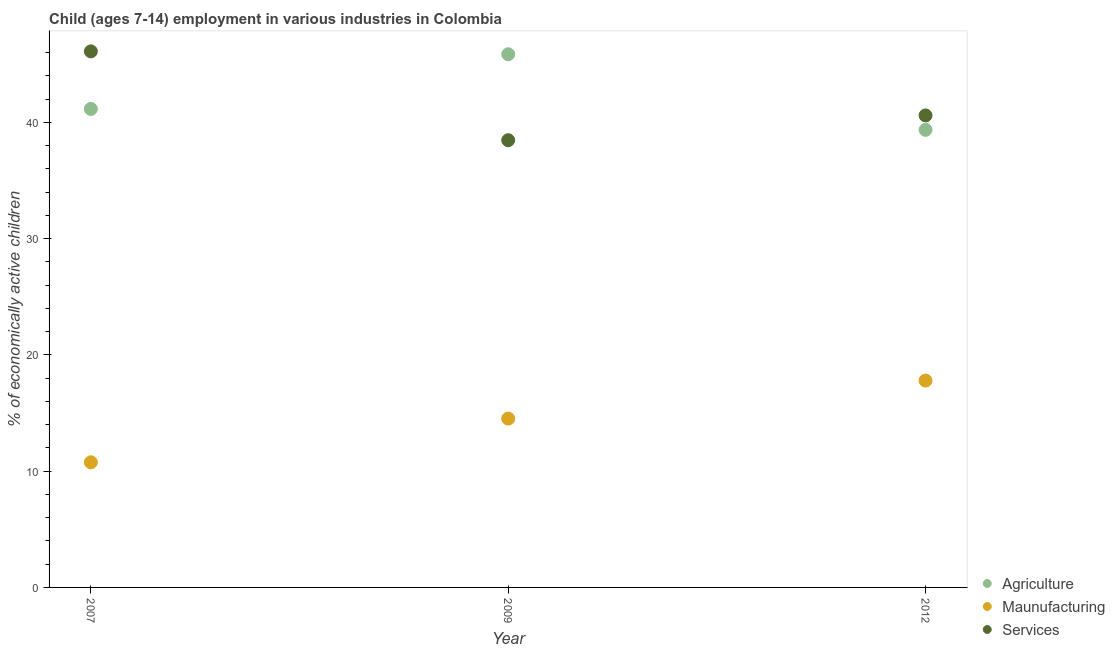What is the percentage of economically active children in manufacturing in 2012?
Offer a terse response. 17.79. Across all years, what is the maximum percentage of economically active children in agriculture?
Your answer should be very brief. 45.85. Across all years, what is the minimum percentage of economically active children in services?
Ensure brevity in your answer.  38.46. In which year was the percentage of economically active children in services minimum?
Ensure brevity in your answer.  2009. What is the total percentage of economically active children in manufacturing in the graph?
Ensure brevity in your answer.  43.07. What is the difference between the percentage of economically active children in services in 2007 and the percentage of economically active children in agriculture in 2012?
Your answer should be compact. 6.75. What is the average percentage of economically active children in services per year?
Provide a succinct answer. 41.72. In the year 2007, what is the difference between the percentage of economically active children in services and percentage of economically active children in manufacturing?
Give a very brief answer. 35.34. What is the ratio of the percentage of economically active children in manufacturing in 2007 to that in 2009?
Keep it short and to the point. 0.74. Is the percentage of economically active children in manufacturing in 2007 less than that in 2009?
Give a very brief answer. Yes. Is the difference between the percentage of economically active children in agriculture in 2007 and 2012 greater than the difference between the percentage of economically active children in manufacturing in 2007 and 2012?
Ensure brevity in your answer.  Yes. What is the difference between the highest and the second highest percentage of economically active children in agriculture?
Keep it short and to the point. 4.7. What is the difference between the highest and the lowest percentage of economically active children in services?
Your answer should be compact. 7.64. In how many years, is the percentage of economically active children in services greater than the average percentage of economically active children in services taken over all years?
Provide a short and direct response. 1. Is the sum of the percentage of economically active children in services in 2007 and 2009 greater than the maximum percentage of economically active children in manufacturing across all years?
Provide a short and direct response. Yes. Is the percentage of economically active children in services strictly greater than the percentage of economically active children in agriculture over the years?
Offer a terse response. No. How many years are there in the graph?
Offer a very short reply. 3. What is the difference between two consecutive major ticks on the Y-axis?
Make the answer very short. 10. Does the graph contain grids?
Your answer should be compact. No. How are the legend labels stacked?
Your response must be concise. Vertical. What is the title of the graph?
Your answer should be very brief. Child (ages 7-14) employment in various industries in Colombia. Does "Agriculture" appear as one of the legend labels in the graph?
Keep it short and to the point. Yes. What is the label or title of the Y-axis?
Offer a terse response. % of economically active children. What is the % of economically active children in Agriculture in 2007?
Keep it short and to the point. 41.15. What is the % of economically active children in Maunufacturing in 2007?
Provide a short and direct response. 10.76. What is the % of economically active children in Services in 2007?
Your answer should be very brief. 46.1. What is the % of economically active children of Agriculture in 2009?
Ensure brevity in your answer.  45.85. What is the % of economically active children of Maunufacturing in 2009?
Your response must be concise. 14.52. What is the % of economically active children of Services in 2009?
Provide a succinct answer. 38.46. What is the % of economically active children in Agriculture in 2012?
Offer a terse response. 39.35. What is the % of economically active children in Maunufacturing in 2012?
Your answer should be compact. 17.79. What is the % of economically active children of Services in 2012?
Your response must be concise. 40.59. Across all years, what is the maximum % of economically active children of Agriculture?
Give a very brief answer. 45.85. Across all years, what is the maximum % of economically active children in Maunufacturing?
Offer a terse response. 17.79. Across all years, what is the maximum % of economically active children in Services?
Provide a succinct answer. 46.1. Across all years, what is the minimum % of economically active children in Agriculture?
Provide a succinct answer. 39.35. Across all years, what is the minimum % of economically active children in Maunufacturing?
Offer a terse response. 10.76. Across all years, what is the minimum % of economically active children of Services?
Your answer should be compact. 38.46. What is the total % of economically active children of Agriculture in the graph?
Your response must be concise. 126.35. What is the total % of economically active children of Maunufacturing in the graph?
Offer a very short reply. 43.07. What is the total % of economically active children of Services in the graph?
Ensure brevity in your answer.  125.15. What is the difference between the % of economically active children of Agriculture in 2007 and that in 2009?
Provide a short and direct response. -4.7. What is the difference between the % of economically active children of Maunufacturing in 2007 and that in 2009?
Ensure brevity in your answer.  -3.76. What is the difference between the % of economically active children in Services in 2007 and that in 2009?
Offer a terse response. 7.64. What is the difference between the % of economically active children of Agriculture in 2007 and that in 2012?
Give a very brief answer. 1.8. What is the difference between the % of economically active children of Maunufacturing in 2007 and that in 2012?
Ensure brevity in your answer.  -7.03. What is the difference between the % of economically active children in Services in 2007 and that in 2012?
Offer a very short reply. 5.51. What is the difference between the % of economically active children in Maunufacturing in 2009 and that in 2012?
Keep it short and to the point. -3.27. What is the difference between the % of economically active children in Services in 2009 and that in 2012?
Give a very brief answer. -2.13. What is the difference between the % of economically active children of Agriculture in 2007 and the % of economically active children of Maunufacturing in 2009?
Give a very brief answer. 26.63. What is the difference between the % of economically active children in Agriculture in 2007 and the % of economically active children in Services in 2009?
Make the answer very short. 2.69. What is the difference between the % of economically active children in Maunufacturing in 2007 and the % of economically active children in Services in 2009?
Keep it short and to the point. -27.7. What is the difference between the % of economically active children in Agriculture in 2007 and the % of economically active children in Maunufacturing in 2012?
Offer a terse response. 23.36. What is the difference between the % of economically active children in Agriculture in 2007 and the % of economically active children in Services in 2012?
Offer a terse response. 0.56. What is the difference between the % of economically active children of Maunufacturing in 2007 and the % of economically active children of Services in 2012?
Provide a succinct answer. -29.83. What is the difference between the % of economically active children in Agriculture in 2009 and the % of economically active children in Maunufacturing in 2012?
Offer a very short reply. 28.06. What is the difference between the % of economically active children of Agriculture in 2009 and the % of economically active children of Services in 2012?
Your response must be concise. 5.26. What is the difference between the % of economically active children in Maunufacturing in 2009 and the % of economically active children in Services in 2012?
Offer a terse response. -26.07. What is the average % of economically active children in Agriculture per year?
Your answer should be compact. 42.12. What is the average % of economically active children of Maunufacturing per year?
Provide a succinct answer. 14.36. What is the average % of economically active children in Services per year?
Keep it short and to the point. 41.72. In the year 2007, what is the difference between the % of economically active children of Agriculture and % of economically active children of Maunufacturing?
Your response must be concise. 30.39. In the year 2007, what is the difference between the % of economically active children in Agriculture and % of economically active children in Services?
Make the answer very short. -4.95. In the year 2007, what is the difference between the % of economically active children of Maunufacturing and % of economically active children of Services?
Provide a succinct answer. -35.34. In the year 2009, what is the difference between the % of economically active children in Agriculture and % of economically active children in Maunufacturing?
Your answer should be very brief. 31.33. In the year 2009, what is the difference between the % of economically active children in Agriculture and % of economically active children in Services?
Offer a terse response. 7.39. In the year 2009, what is the difference between the % of economically active children of Maunufacturing and % of economically active children of Services?
Your answer should be very brief. -23.94. In the year 2012, what is the difference between the % of economically active children in Agriculture and % of economically active children in Maunufacturing?
Provide a succinct answer. 21.56. In the year 2012, what is the difference between the % of economically active children in Agriculture and % of economically active children in Services?
Your answer should be compact. -1.24. In the year 2012, what is the difference between the % of economically active children in Maunufacturing and % of economically active children in Services?
Provide a succinct answer. -22.8. What is the ratio of the % of economically active children of Agriculture in 2007 to that in 2009?
Provide a succinct answer. 0.9. What is the ratio of the % of economically active children in Maunufacturing in 2007 to that in 2009?
Make the answer very short. 0.74. What is the ratio of the % of economically active children in Services in 2007 to that in 2009?
Offer a very short reply. 1.2. What is the ratio of the % of economically active children in Agriculture in 2007 to that in 2012?
Make the answer very short. 1.05. What is the ratio of the % of economically active children of Maunufacturing in 2007 to that in 2012?
Provide a short and direct response. 0.6. What is the ratio of the % of economically active children in Services in 2007 to that in 2012?
Your response must be concise. 1.14. What is the ratio of the % of economically active children in Agriculture in 2009 to that in 2012?
Make the answer very short. 1.17. What is the ratio of the % of economically active children of Maunufacturing in 2009 to that in 2012?
Provide a succinct answer. 0.82. What is the ratio of the % of economically active children of Services in 2009 to that in 2012?
Offer a very short reply. 0.95. What is the difference between the highest and the second highest % of economically active children in Maunufacturing?
Make the answer very short. 3.27. What is the difference between the highest and the second highest % of economically active children of Services?
Ensure brevity in your answer.  5.51. What is the difference between the highest and the lowest % of economically active children in Agriculture?
Offer a very short reply. 6.5. What is the difference between the highest and the lowest % of economically active children of Maunufacturing?
Provide a short and direct response. 7.03. What is the difference between the highest and the lowest % of economically active children in Services?
Provide a short and direct response. 7.64. 